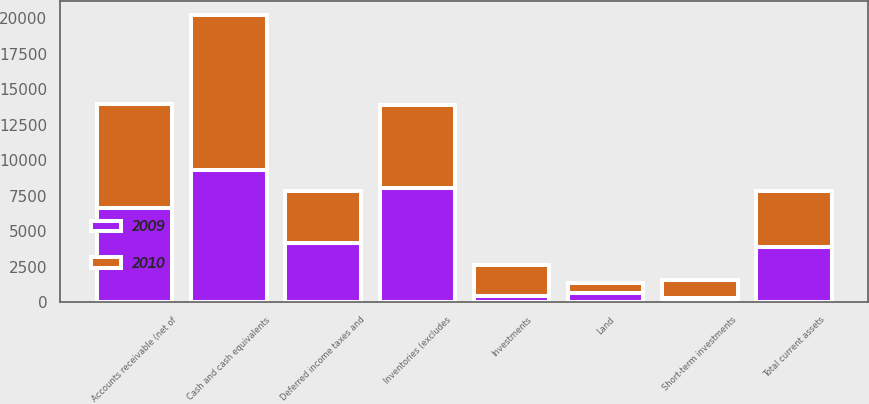Convert chart to OTSL. <chart><loc_0><loc_0><loc_500><loc_500><stacked_bar_chart><ecel><fcel>Cash and cash equivalents<fcel>Short-term investments<fcel>Accounts receivable (net of<fcel>Inventories (excludes<fcel>Deferred income taxes and<fcel>Total current assets<fcel>Investments<fcel>Land<nl><fcel>2010<fcel>10900<fcel>1301<fcel>7344<fcel>5868<fcel>3651<fcel>3914<fcel>2175<fcel>658<nl><fcel>2009<fcel>9311<fcel>293<fcel>6603<fcel>8048<fcel>4177<fcel>3914<fcel>432<fcel>667<nl></chart> 